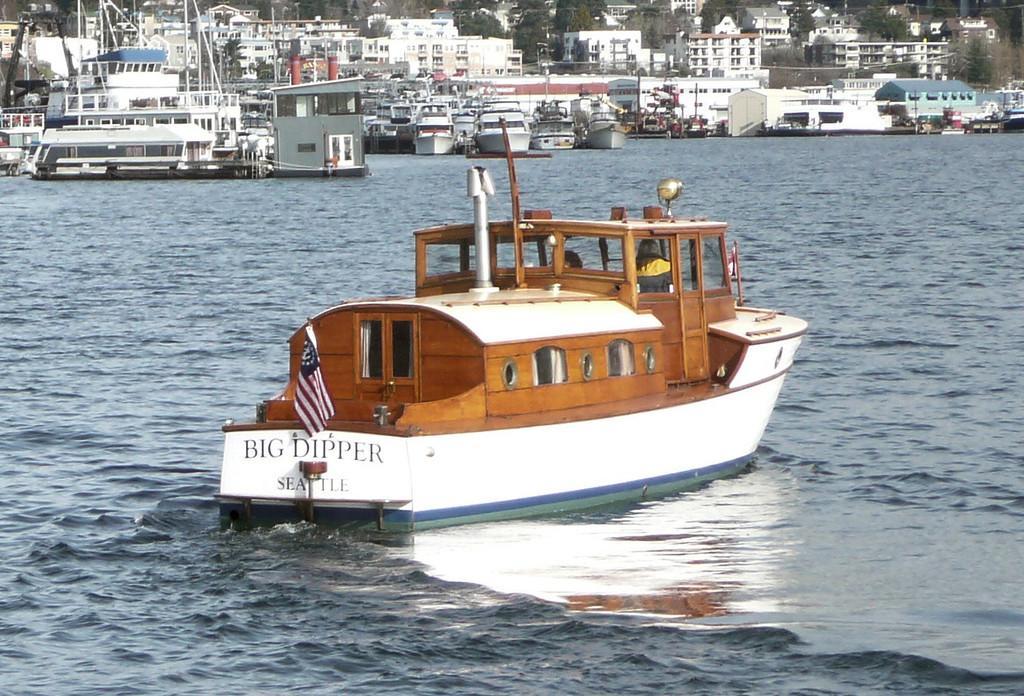Could you give a brief overview of what you see in this image? In the image there is boat moving in the sea, behind it there are many boats followed by many buildings in the background. 